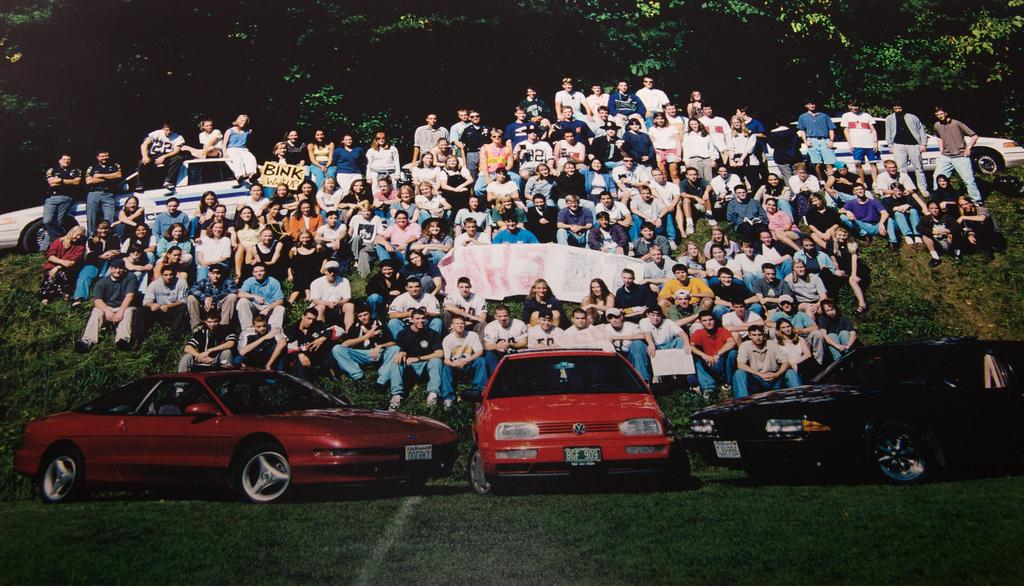What are the people in the image doing? There are people sitting and standing in the image. What are some of the people holding? Some of the people are holding a banner. What can be seen in the background of the image? There are trees in the background of the image. What type of terrain is visible in the image? There is grass in the image. What else can be seen in the image besides people and trees? There are cars visible in the image. What type of education is being taught in the scene? There is no indication of any educational activity in the image; it primarily features people, a banner, cars, grass, and trees. 